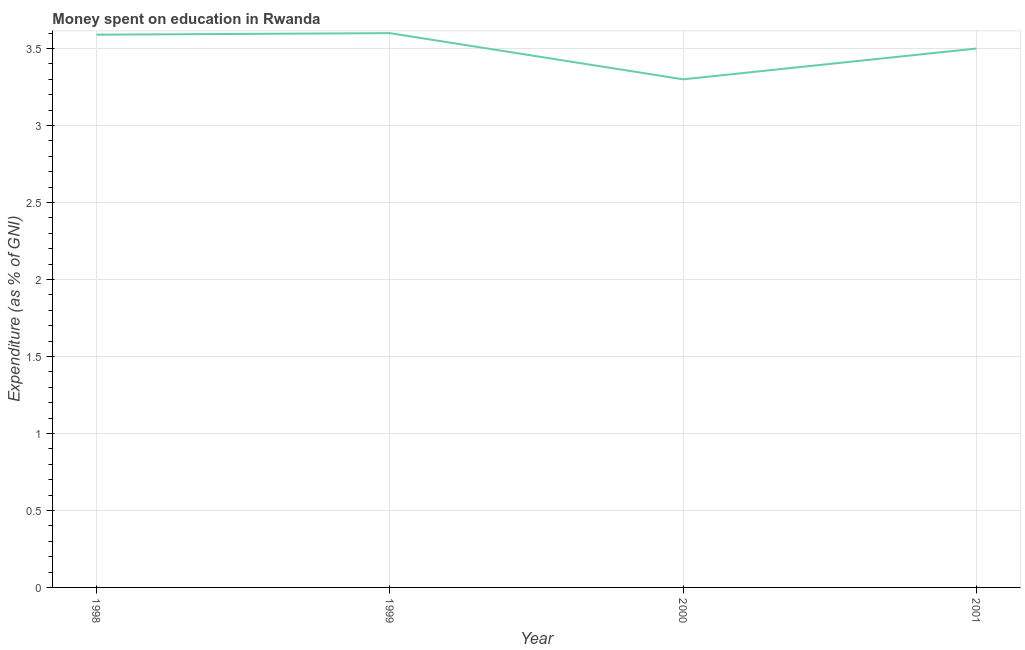Across all years, what is the minimum expenditure on education?
Provide a short and direct response. 3.3. What is the sum of the expenditure on education?
Ensure brevity in your answer.  13.99. What is the difference between the expenditure on education in 1999 and 2001?
Provide a succinct answer. 0.1. What is the average expenditure on education per year?
Your answer should be compact. 3.5. What is the median expenditure on education?
Make the answer very short. 3.54. Do a majority of the years between 1998 and 2000 (inclusive) have expenditure on education greater than 1.4 %?
Your answer should be compact. Yes. What is the ratio of the expenditure on education in 1999 to that in 2001?
Make the answer very short. 1.03. Is the difference between the expenditure on education in 1999 and 2001 greater than the difference between any two years?
Make the answer very short. No. What is the difference between the highest and the second highest expenditure on education?
Offer a very short reply. 0.01. What is the difference between the highest and the lowest expenditure on education?
Make the answer very short. 0.3. How many lines are there?
Offer a terse response. 1. How many years are there in the graph?
Offer a terse response. 4. What is the difference between two consecutive major ticks on the Y-axis?
Your response must be concise. 0.5. Does the graph contain any zero values?
Keep it short and to the point. No. Does the graph contain grids?
Your answer should be very brief. Yes. What is the title of the graph?
Provide a succinct answer. Money spent on education in Rwanda. What is the label or title of the X-axis?
Keep it short and to the point. Year. What is the label or title of the Y-axis?
Provide a short and direct response. Expenditure (as % of GNI). What is the Expenditure (as % of GNI) in 1998?
Offer a very short reply. 3.59. What is the Expenditure (as % of GNI) in 1999?
Offer a very short reply. 3.6. What is the Expenditure (as % of GNI) of 2000?
Your answer should be very brief. 3.3. What is the Expenditure (as % of GNI) of 2001?
Give a very brief answer. 3.5. What is the difference between the Expenditure (as % of GNI) in 1998 and 1999?
Offer a terse response. -0.01. What is the difference between the Expenditure (as % of GNI) in 1998 and 2000?
Provide a succinct answer. 0.29. What is the difference between the Expenditure (as % of GNI) in 1998 and 2001?
Keep it short and to the point. 0.09. What is the difference between the Expenditure (as % of GNI) in 1999 and 2000?
Provide a succinct answer. 0.3. What is the ratio of the Expenditure (as % of GNI) in 1998 to that in 1999?
Your answer should be compact. 1. What is the ratio of the Expenditure (as % of GNI) in 1998 to that in 2000?
Offer a very short reply. 1.09. What is the ratio of the Expenditure (as % of GNI) in 1998 to that in 2001?
Offer a terse response. 1.03. What is the ratio of the Expenditure (as % of GNI) in 1999 to that in 2000?
Your answer should be very brief. 1.09. What is the ratio of the Expenditure (as % of GNI) in 2000 to that in 2001?
Ensure brevity in your answer.  0.94. 